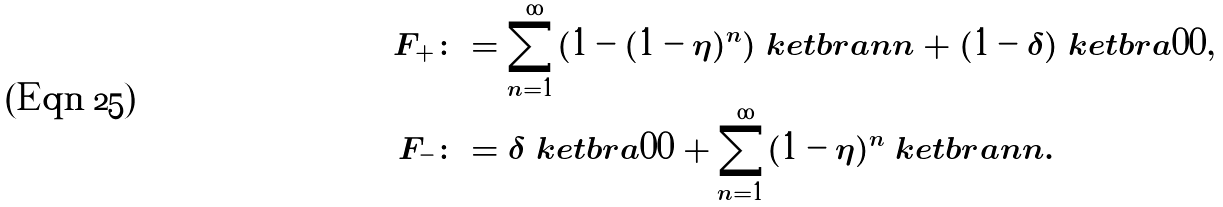Convert formula to latex. <formula><loc_0><loc_0><loc_500><loc_500>F _ { + } & \colon = \sum _ { n = 1 } ^ { \infty } ( 1 - ( 1 - \eta ) ^ { n } ) \ k e t b r a { n } { n } + ( 1 - \delta ) \ k e t b r a { 0 } { 0 } , \\ F _ { - } & \colon = \delta \ k e t b r a { 0 } { 0 } + \sum _ { n = 1 } ^ { \infty } ( 1 - \eta ) ^ { n } \ k e t b r a { n } { n } .</formula> 